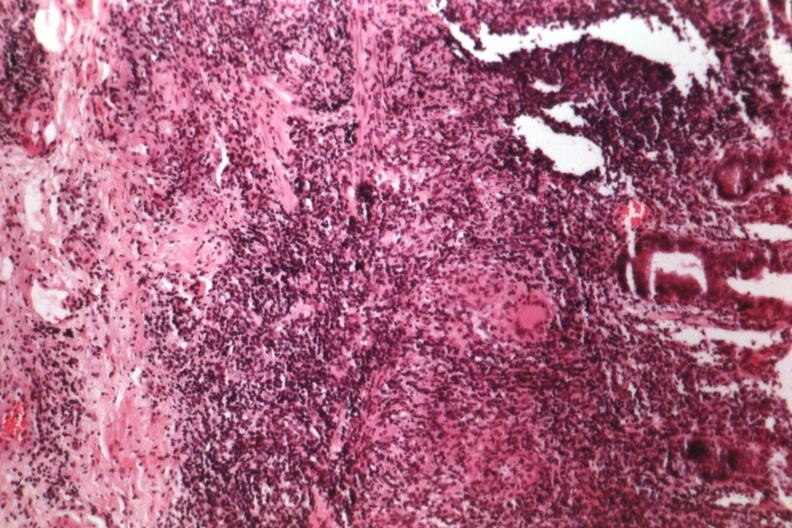what does this image show?
Answer the question using a single word or phrase. Source of granulomatous colitis 